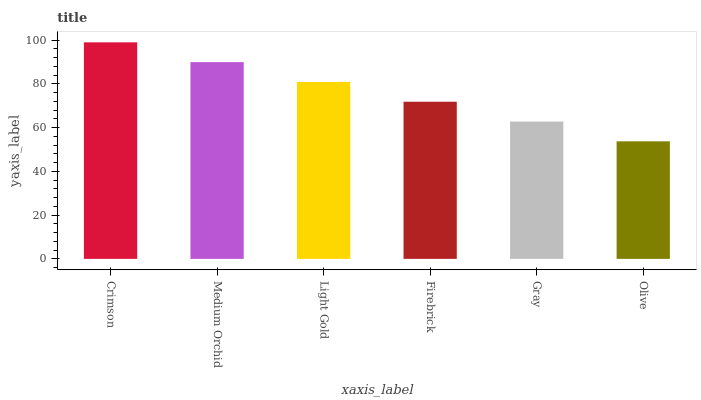Is Olive the minimum?
Answer yes or no. Yes. Is Crimson the maximum?
Answer yes or no. Yes. Is Medium Orchid the minimum?
Answer yes or no. No. Is Medium Orchid the maximum?
Answer yes or no. No. Is Crimson greater than Medium Orchid?
Answer yes or no. Yes. Is Medium Orchid less than Crimson?
Answer yes or no. Yes. Is Medium Orchid greater than Crimson?
Answer yes or no. No. Is Crimson less than Medium Orchid?
Answer yes or no. No. Is Light Gold the high median?
Answer yes or no. Yes. Is Firebrick the low median?
Answer yes or no. Yes. Is Firebrick the high median?
Answer yes or no. No. Is Crimson the low median?
Answer yes or no. No. 